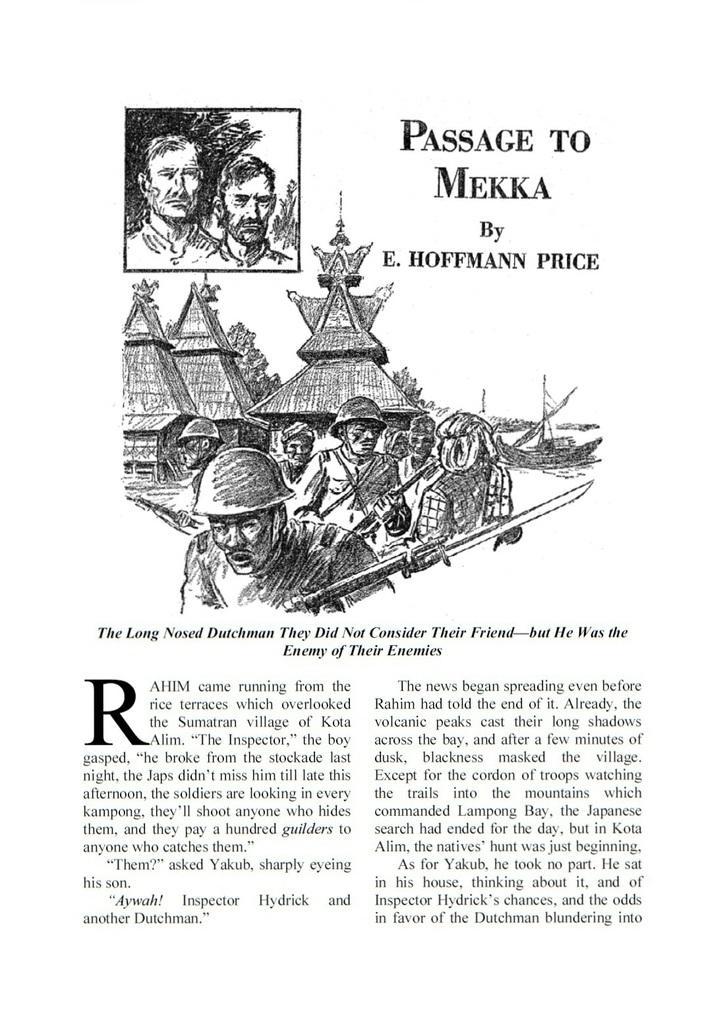In one or two sentences, can you explain what this image depicts? In this picture we can see a magazine paper with drawing sketch of some military men. On the top we can see "Passage to Mecca" is written. 